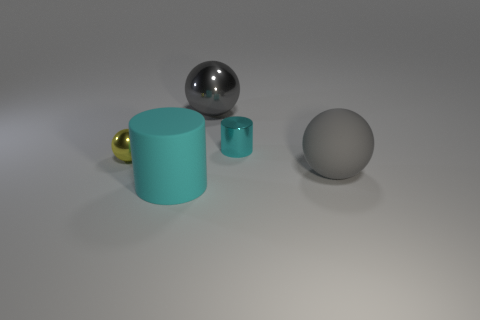What is the lighting like in this image? Is it coming from a particular direction? The lighting in the image is diffused and seems to be coming from above, as indicated by the soft shadows cast directly under the objects. Do the materials of the objects reflect light differently? Yes, the metallic objects reflect light strongly and have clear highlights, whereas the matte gray sphere diffuses light and does not have prominent reflections. 